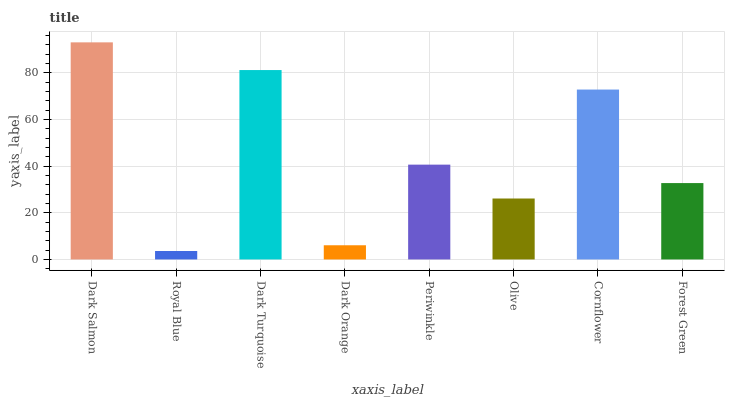Is Dark Turquoise the minimum?
Answer yes or no. No. Is Dark Turquoise the maximum?
Answer yes or no. No. Is Dark Turquoise greater than Royal Blue?
Answer yes or no. Yes. Is Royal Blue less than Dark Turquoise?
Answer yes or no. Yes. Is Royal Blue greater than Dark Turquoise?
Answer yes or no. No. Is Dark Turquoise less than Royal Blue?
Answer yes or no. No. Is Periwinkle the high median?
Answer yes or no. Yes. Is Forest Green the low median?
Answer yes or no. Yes. Is Dark Orange the high median?
Answer yes or no. No. Is Dark Turquoise the low median?
Answer yes or no. No. 